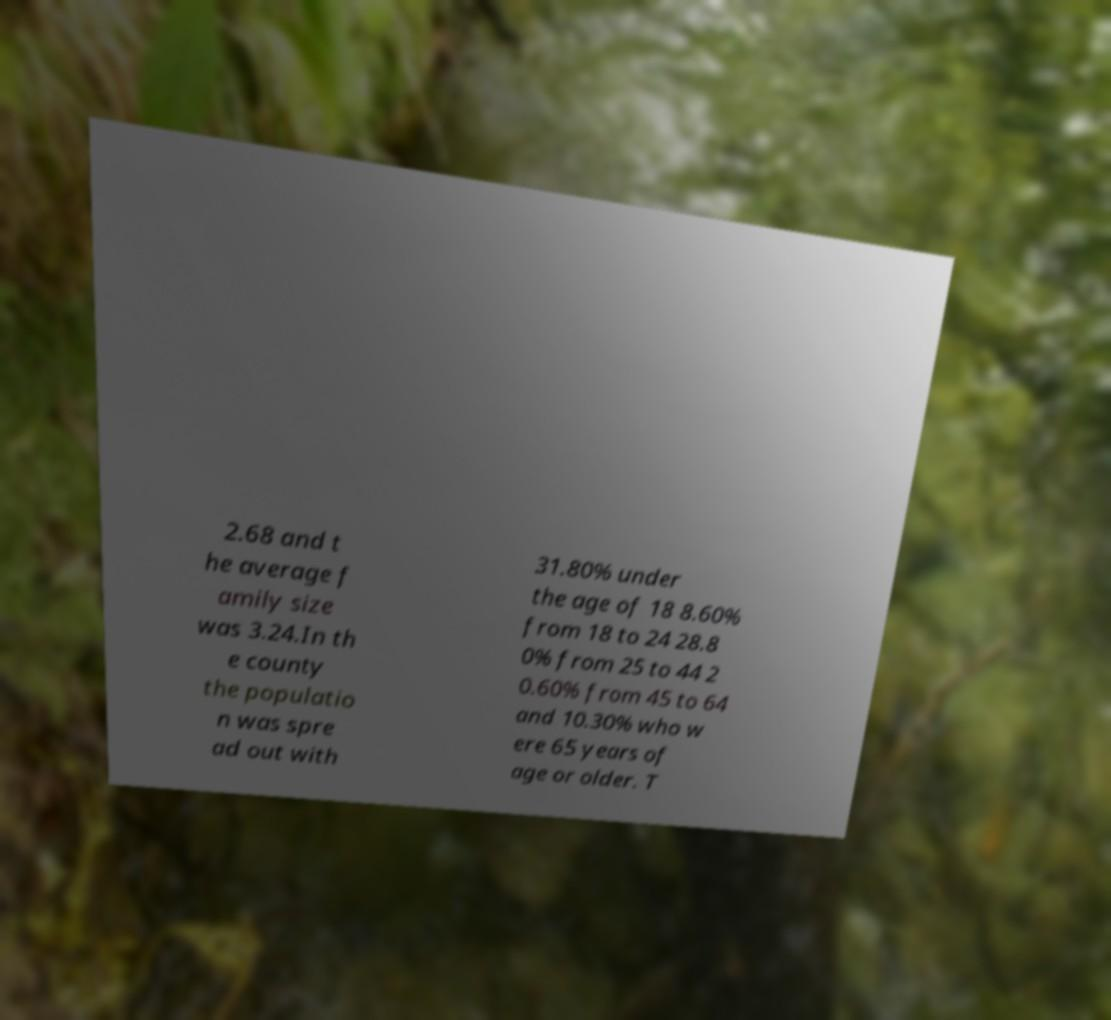Can you accurately transcribe the text from the provided image for me? 2.68 and t he average f amily size was 3.24.In th e county the populatio n was spre ad out with 31.80% under the age of 18 8.60% from 18 to 24 28.8 0% from 25 to 44 2 0.60% from 45 to 64 and 10.30% who w ere 65 years of age or older. T 